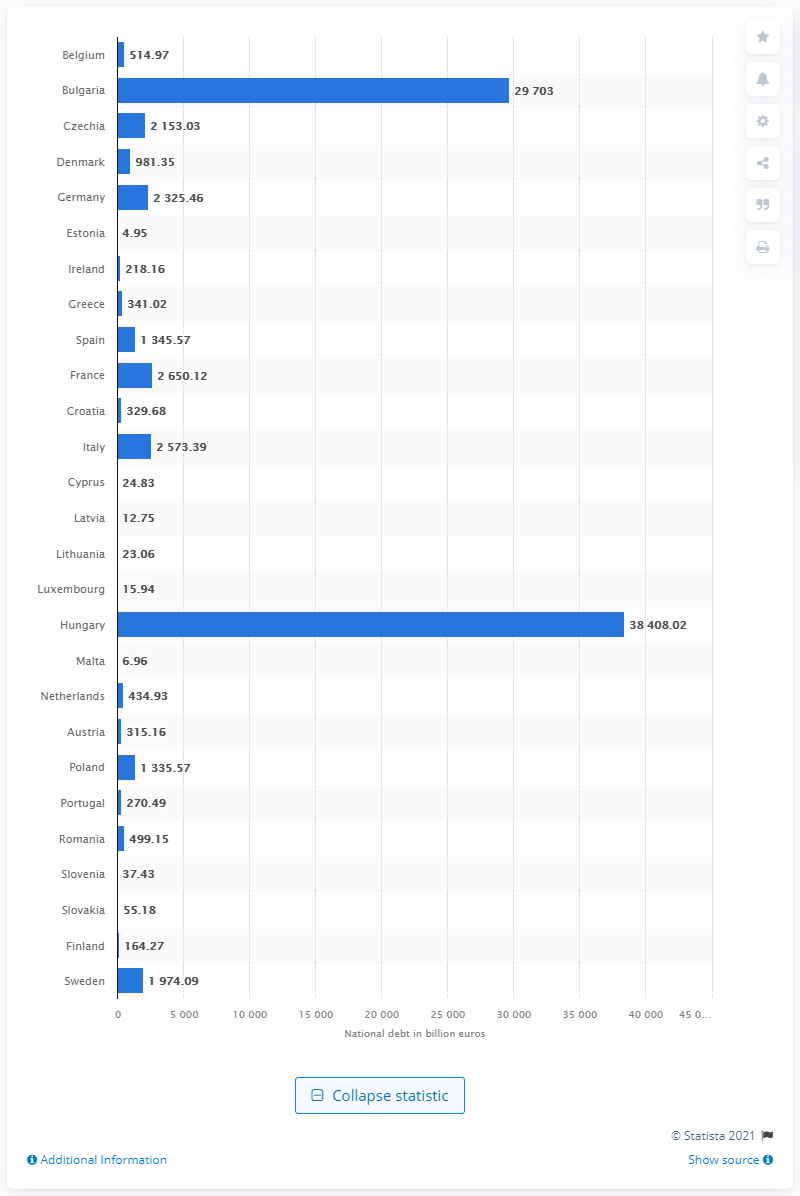Indicate a few pertinent items in this graphic. In the third quarter of 2020, Greece's national debt was 341.02. 